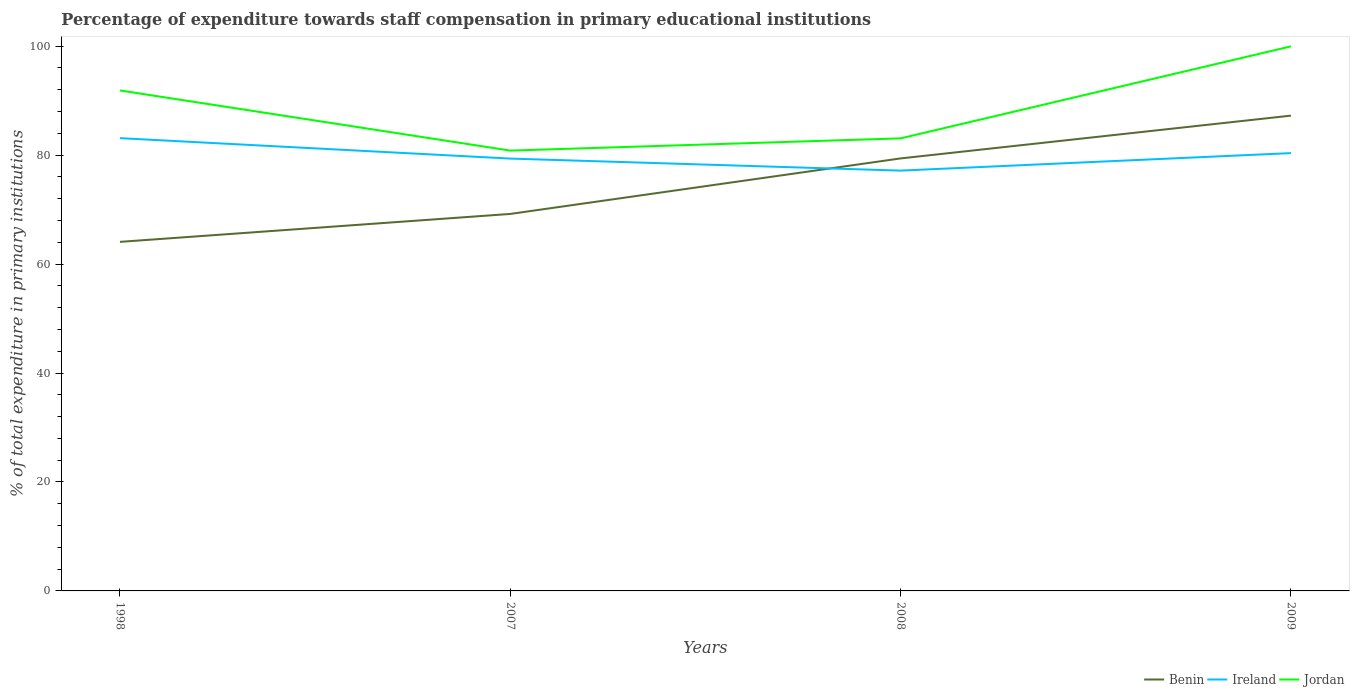Is the number of lines equal to the number of legend labels?
Ensure brevity in your answer.  Yes. Across all years, what is the maximum percentage of expenditure towards staff compensation in Jordan?
Your answer should be compact. 80.83. In which year was the percentage of expenditure towards staff compensation in Ireland maximum?
Offer a terse response. 2008. What is the total percentage of expenditure towards staff compensation in Jordan in the graph?
Provide a succinct answer. -2.25. What is the difference between the highest and the second highest percentage of expenditure towards staff compensation in Ireland?
Your answer should be compact. 5.96. What is the difference between the highest and the lowest percentage of expenditure towards staff compensation in Ireland?
Keep it short and to the point. 2. Is the percentage of expenditure towards staff compensation in Benin strictly greater than the percentage of expenditure towards staff compensation in Jordan over the years?
Provide a short and direct response. Yes. How many years are there in the graph?
Your answer should be very brief. 4. What is the difference between two consecutive major ticks on the Y-axis?
Your response must be concise. 20. Where does the legend appear in the graph?
Keep it short and to the point. Bottom right. What is the title of the graph?
Your response must be concise. Percentage of expenditure towards staff compensation in primary educational institutions. Does "Iceland" appear as one of the legend labels in the graph?
Offer a terse response. No. What is the label or title of the X-axis?
Offer a terse response. Years. What is the label or title of the Y-axis?
Provide a succinct answer. % of total expenditure in primary institutions. What is the % of total expenditure in primary institutions of Benin in 1998?
Your response must be concise. 64.08. What is the % of total expenditure in primary institutions in Ireland in 1998?
Provide a succinct answer. 83.11. What is the % of total expenditure in primary institutions in Jordan in 1998?
Give a very brief answer. 91.87. What is the % of total expenditure in primary institutions in Benin in 2007?
Your answer should be compact. 69.2. What is the % of total expenditure in primary institutions in Ireland in 2007?
Your answer should be compact. 79.36. What is the % of total expenditure in primary institutions in Jordan in 2007?
Give a very brief answer. 80.83. What is the % of total expenditure in primary institutions of Benin in 2008?
Provide a succinct answer. 79.39. What is the % of total expenditure in primary institutions in Ireland in 2008?
Make the answer very short. 77.15. What is the % of total expenditure in primary institutions of Jordan in 2008?
Offer a very short reply. 83.08. What is the % of total expenditure in primary institutions in Benin in 2009?
Ensure brevity in your answer.  87.25. What is the % of total expenditure in primary institutions of Ireland in 2009?
Your response must be concise. 80.37. What is the % of total expenditure in primary institutions of Jordan in 2009?
Your answer should be compact. 99.96. Across all years, what is the maximum % of total expenditure in primary institutions of Benin?
Provide a succinct answer. 87.25. Across all years, what is the maximum % of total expenditure in primary institutions in Ireland?
Your response must be concise. 83.11. Across all years, what is the maximum % of total expenditure in primary institutions of Jordan?
Keep it short and to the point. 99.96. Across all years, what is the minimum % of total expenditure in primary institutions of Benin?
Make the answer very short. 64.08. Across all years, what is the minimum % of total expenditure in primary institutions in Ireland?
Your response must be concise. 77.15. Across all years, what is the minimum % of total expenditure in primary institutions of Jordan?
Offer a very short reply. 80.83. What is the total % of total expenditure in primary institutions in Benin in the graph?
Offer a very short reply. 299.92. What is the total % of total expenditure in primary institutions in Ireland in the graph?
Offer a very short reply. 320. What is the total % of total expenditure in primary institutions of Jordan in the graph?
Provide a succinct answer. 355.74. What is the difference between the % of total expenditure in primary institutions in Benin in 1998 and that in 2007?
Ensure brevity in your answer.  -5.13. What is the difference between the % of total expenditure in primary institutions of Ireland in 1998 and that in 2007?
Keep it short and to the point. 3.75. What is the difference between the % of total expenditure in primary institutions of Jordan in 1998 and that in 2007?
Provide a succinct answer. 11.04. What is the difference between the % of total expenditure in primary institutions of Benin in 1998 and that in 2008?
Give a very brief answer. -15.32. What is the difference between the % of total expenditure in primary institutions in Ireland in 1998 and that in 2008?
Ensure brevity in your answer.  5.96. What is the difference between the % of total expenditure in primary institutions of Jordan in 1998 and that in 2008?
Provide a succinct answer. 8.79. What is the difference between the % of total expenditure in primary institutions in Benin in 1998 and that in 2009?
Provide a succinct answer. -23.17. What is the difference between the % of total expenditure in primary institutions in Ireland in 1998 and that in 2009?
Ensure brevity in your answer.  2.75. What is the difference between the % of total expenditure in primary institutions of Jordan in 1998 and that in 2009?
Your response must be concise. -8.09. What is the difference between the % of total expenditure in primary institutions of Benin in 2007 and that in 2008?
Make the answer very short. -10.19. What is the difference between the % of total expenditure in primary institutions in Ireland in 2007 and that in 2008?
Offer a terse response. 2.21. What is the difference between the % of total expenditure in primary institutions in Jordan in 2007 and that in 2008?
Give a very brief answer. -2.25. What is the difference between the % of total expenditure in primary institutions of Benin in 2007 and that in 2009?
Make the answer very short. -18.05. What is the difference between the % of total expenditure in primary institutions in Ireland in 2007 and that in 2009?
Provide a short and direct response. -1. What is the difference between the % of total expenditure in primary institutions of Jordan in 2007 and that in 2009?
Provide a short and direct response. -19.14. What is the difference between the % of total expenditure in primary institutions in Benin in 2008 and that in 2009?
Provide a short and direct response. -7.85. What is the difference between the % of total expenditure in primary institutions in Ireland in 2008 and that in 2009?
Offer a very short reply. -3.21. What is the difference between the % of total expenditure in primary institutions in Jordan in 2008 and that in 2009?
Offer a terse response. -16.89. What is the difference between the % of total expenditure in primary institutions of Benin in 1998 and the % of total expenditure in primary institutions of Ireland in 2007?
Your answer should be very brief. -15.29. What is the difference between the % of total expenditure in primary institutions in Benin in 1998 and the % of total expenditure in primary institutions in Jordan in 2007?
Your response must be concise. -16.75. What is the difference between the % of total expenditure in primary institutions of Ireland in 1998 and the % of total expenditure in primary institutions of Jordan in 2007?
Ensure brevity in your answer.  2.28. What is the difference between the % of total expenditure in primary institutions in Benin in 1998 and the % of total expenditure in primary institutions in Ireland in 2008?
Keep it short and to the point. -13.08. What is the difference between the % of total expenditure in primary institutions in Benin in 1998 and the % of total expenditure in primary institutions in Jordan in 2008?
Offer a terse response. -19. What is the difference between the % of total expenditure in primary institutions in Ireland in 1998 and the % of total expenditure in primary institutions in Jordan in 2008?
Your response must be concise. 0.04. What is the difference between the % of total expenditure in primary institutions of Benin in 1998 and the % of total expenditure in primary institutions of Ireland in 2009?
Your answer should be very brief. -16.29. What is the difference between the % of total expenditure in primary institutions of Benin in 1998 and the % of total expenditure in primary institutions of Jordan in 2009?
Your response must be concise. -35.89. What is the difference between the % of total expenditure in primary institutions of Ireland in 1998 and the % of total expenditure in primary institutions of Jordan in 2009?
Keep it short and to the point. -16.85. What is the difference between the % of total expenditure in primary institutions of Benin in 2007 and the % of total expenditure in primary institutions of Ireland in 2008?
Provide a short and direct response. -7.95. What is the difference between the % of total expenditure in primary institutions in Benin in 2007 and the % of total expenditure in primary institutions in Jordan in 2008?
Make the answer very short. -13.87. What is the difference between the % of total expenditure in primary institutions in Ireland in 2007 and the % of total expenditure in primary institutions in Jordan in 2008?
Your answer should be very brief. -3.71. What is the difference between the % of total expenditure in primary institutions in Benin in 2007 and the % of total expenditure in primary institutions in Ireland in 2009?
Give a very brief answer. -11.17. What is the difference between the % of total expenditure in primary institutions in Benin in 2007 and the % of total expenditure in primary institutions in Jordan in 2009?
Your answer should be compact. -30.76. What is the difference between the % of total expenditure in primary institutions in Ireland in 2007 and the % of total expenditure in primary institutions in Jordan in 2009?
Your response must be concise. -20.6. What is the difference between the % of total expenditure in primary institutions of Benin in 2008 and the % of total expenditure in primary institutions of Ireland in 2009?
Offer a terse response. -0.97. What is the difference between the % of total expenditure in primary institutions of Benin in 2008 and the % of total expenditure in primary institutions of Jordan in 2009?
Your answer should be very brief. -20.57. What is the difference between the % of total expenditure in primary institutions of Ireland in 2008 and the % of total expenditure in primary institutions of Jordan in 2009?
Provide a succinct answer. -22.81. What is the average % of total expenditure in primary institutions in Benin per year?
Give a very brief answer. 74.98. What is the average % of total expenditure in primary institutions of Ireland per year?
Your response must be concise. 80. What is the average % of total expenditure in primary institutions in Jordan per year?
Make the answer very short. 88.93. In the year 1998, what is the difference between the % of total expenditure in primary institutions in Benin and % of total expenditure in primary institutions in Ireland?
Offer a terse response. -19.04. In the year 1998, what is the difference between the % of total expenditure in primary institutions in Benin and % of total expenditure in primary institutions in Jordan?
Your answer should be compact. -27.79. In the year 1998, what is the difference between the % of total expenditure in primary institutions of Ireland and % of total expenditure in primary institutions of Jordan?
Your response must be concise. -8.76. In the year 2007, what is the difference between the % of total expenditure in primary institutions of Benin and % of total expenditure in primary institutions of Ireland?
Make the answer very short. -10.16. In the year 2007, what is the difference between the % of total expenditure in primary institutions in Benin and % of total expenditure in primary institutions in Jordan?
Your answer should be very brief. -11.63. In the year 2007, what is the difference between the % of total expenditure in primary institutions in Ireland and % of total expenditure in primary institutions in Jordan?
Your answer should be very brief. -1.46. In the year 2008, what is the difference between the % of total expenditure in primary institutions in Benin and % of total expenditure in primary institutions in Ireland?
Keep it short and to the point. 2.24. In the year 2008, what is the difference between the % of total expenditure in primary institutions in Benin and % of total expenditure in primary institutions in Jordan?
Provide a short and direct response. -3.68. In the year 2008, what is the difference between the % of total expenditure in primary institutions of Ireland and % of total expenditure in primary institutions of Jordan?
Offer a terse response. -5.92. In the year 2009, what is the difference between the % of total expenditure in primary institutions in Benin and % of total expenditure in primary institutions in Ireland?
Provide a succinct answer. 6.88. In the year 2009, what is the difference between the % of total expenditure in primary institutions in Benin and % of total expenditure in primary institutions in Jordan?
Your answer should be very brief. -12.72. In the year 2009, what is the difference between the % of total expenditure in primary institutions of Ireland and % of total expenditure in primary institutions of Jordan?
Provide a short and direct response. -19.6. What is the ratio of the % of total expenditure in primary institutions in Benin in 1998 to that in 2007?
Provide a short and direct response. 0.93. What is the ratio of the % of total expenditure in primary institutions in Ireland in 1998 to that in 2007?
Offer a terse response. 1.05. What is the ratio of the % of total expenditure in primary institutions of Jordan in 1998 to that in 2007?
Your response must be concise. 1.14. What is the ratio of the % of total expenditure in primary institutions of Benin in 1998 to that in 2008?
Provide a short and direct response. 0.81. What is the ratio of the % of total expenditure in primary institutions of Ireland in 1998 to that in 2008?
Provide a short and direct response. 1.08. What is the ratio of the % of total expenditure in primary institutions in Jordan in 1998 to that in 2008?
Keep it short and to the point. 1.11. What is the ratio of the % of total expenditure in primary institutions of Benin in 1998 to that in 2009?
Ensure brevity in your answer.  0.73. What is the ratio of the % of total expenditure in primary institutions of Ireland in 1998 to that in 2009?
Your response must be concise. 1.03. What is the ratio of the % of total expenditure in primary institutions in Jordan in 1998 to that in 2009?
Provide a short and direct response. 0.92. What is the ratio of the % of total expenditure in primary institutions in Benin in 2007 to that in 2008?
Offer a very short reply. 0.87. What is the ratio of the % of total expenditure in primary institutions in Ireland in 2007 to that in 2008?
Provide a short and direct response. 1.03. What is the ratio of the % of total expenditure in primary institutions of Jordan in 2007 to that in 2008?
Ensure brevity in your answer.  0.97. What is the ratio of the % of total expenditure in primary institutions of Benin in 2007 to that in 2009?
Provide a succinct answer. 0.79. What is the ratio of the % of total expenditure in primary institutions in Ireland in 2007 to that in 2009?
Your answer should be very brief. 0.99. What is the ratio of the % of total expenditure in primary institutions of Jordan in 2007 to that in 2009?
Your response must be concise. 0.81. What is the ratio of the % of total expenditure in primary institutions of Benin in 2008 to that in 2009?
Ensure brevity in your answer.  0.91. What is the ratio of the % of total expenditure in primary institutions of Jordan in 2008 to that in 2009?
Ensure brevity in your answer.  0.83. What is the difference between the highest and the second highest % of total expenditure in primary institutions of Benin?
Give a very brief answer. 7.85. What is the difference between the highest and the second highest % of total expenditure in primary institutions of Ireland?
Provide a short and direct response. 2.75. What is the difference between the highest and the second highest % of total expenditure in primary institutions of Jordan?
Your answer should be compact. 8.09. What is the difference between the highest and the lowest % of total expenditure in primary institutions of Benin?
Ensure brevity in your answer.  23.17. What is the difference between the highest and the lowest % of total expenditure in primary institutions in Ireland?
Offer a terse response. 5.96. What is the difference between the highest and the lowest % of total expenditure in primary institutions of Jordan?
Provide a short and direct response. 19.14. 